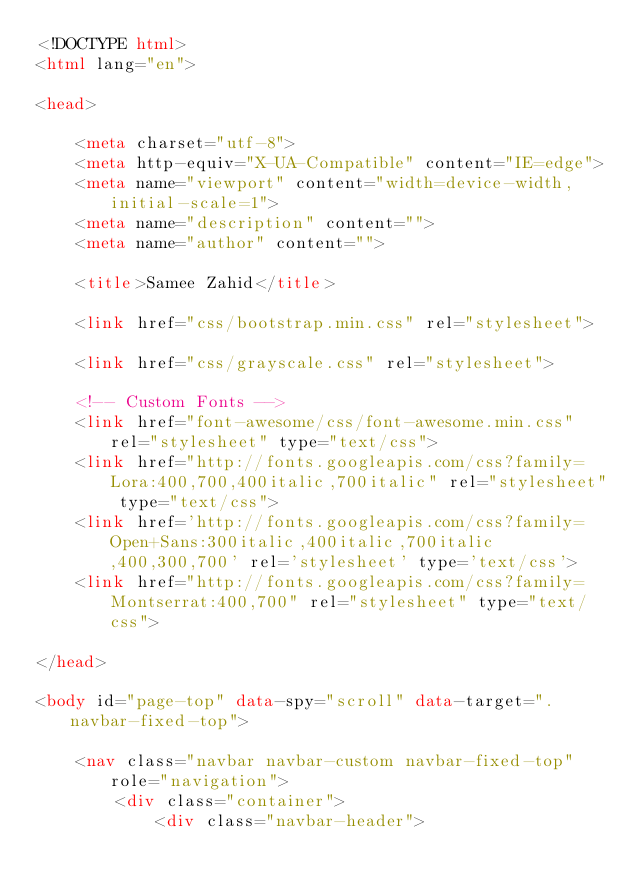<code> <loc_0><loc_0><loc_500><loc_500><_HTML_><!DOCTYPE html>
<html lang="en">

<head>

    <meta charset="utf-8">
    <meta http-equiv="X-UA-Compatible" content="IE=edge">
    <meta name="viewport" content="width=device-width, initial-scale=1">
    <meta name="description" content="">
    <meta name="author" content="">

    <title>Samee Zahid</title>

    <link href="css/bootstrap.min.css" rel="stylesheet">

    <link href="css/grayscale.css" rel="stylesheet">

    <!-- Custom Fonts -->
    <link href="font-awesome/css/font-awesome.min.css" rel="stylesheet" type="text/css">
    <link href="http://fonts.googleapis.com/css?family=Lora:400,700,400italic,700italic" rel="stylesheet" type="text/css">
    <link href='http://fonts.googleapis.com/css?family=Open+Sans:300italic,400italic,700italic,400,300,700' rel='stylesheet' type='text/css'>
    <link href="http://fonts.googleapis.com/css?family=Montserrat:400,700" rel="stylesheet" type="text/css">

</head>

<body id="page-top" data-spy="scroll" data-target=".navbar-fixed-top">

    <nav class="navbar navbar-custom navbar-fixed-top" role="navigation">
        <div class="container">
            <div class="navbar-header"></code> 